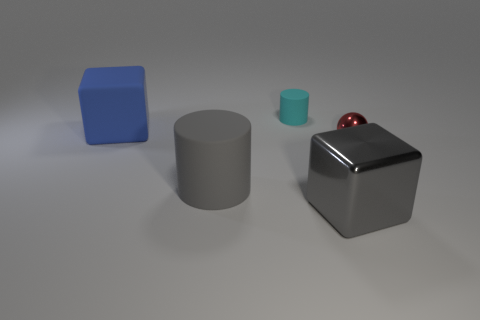Add 2 gray rubber objects. How many objects exist? 7 Subtract all cylinders. How many objects are left? 3 Subtract 0 green blocks. How many objects are left? 5 Subtract all red spheres. Subtract all large gray cylinders. How many objects are left? 3 Add 3 gray cylinders. How many gray cylinders are left? 4 Add 5 tiny matte cylinders. How many tiny matte cylinders exist? 6 